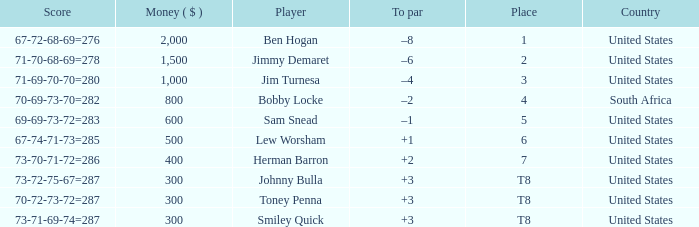What is the to par for a player who has a score of 73-70-71-72, totaling 286? 2.0. 